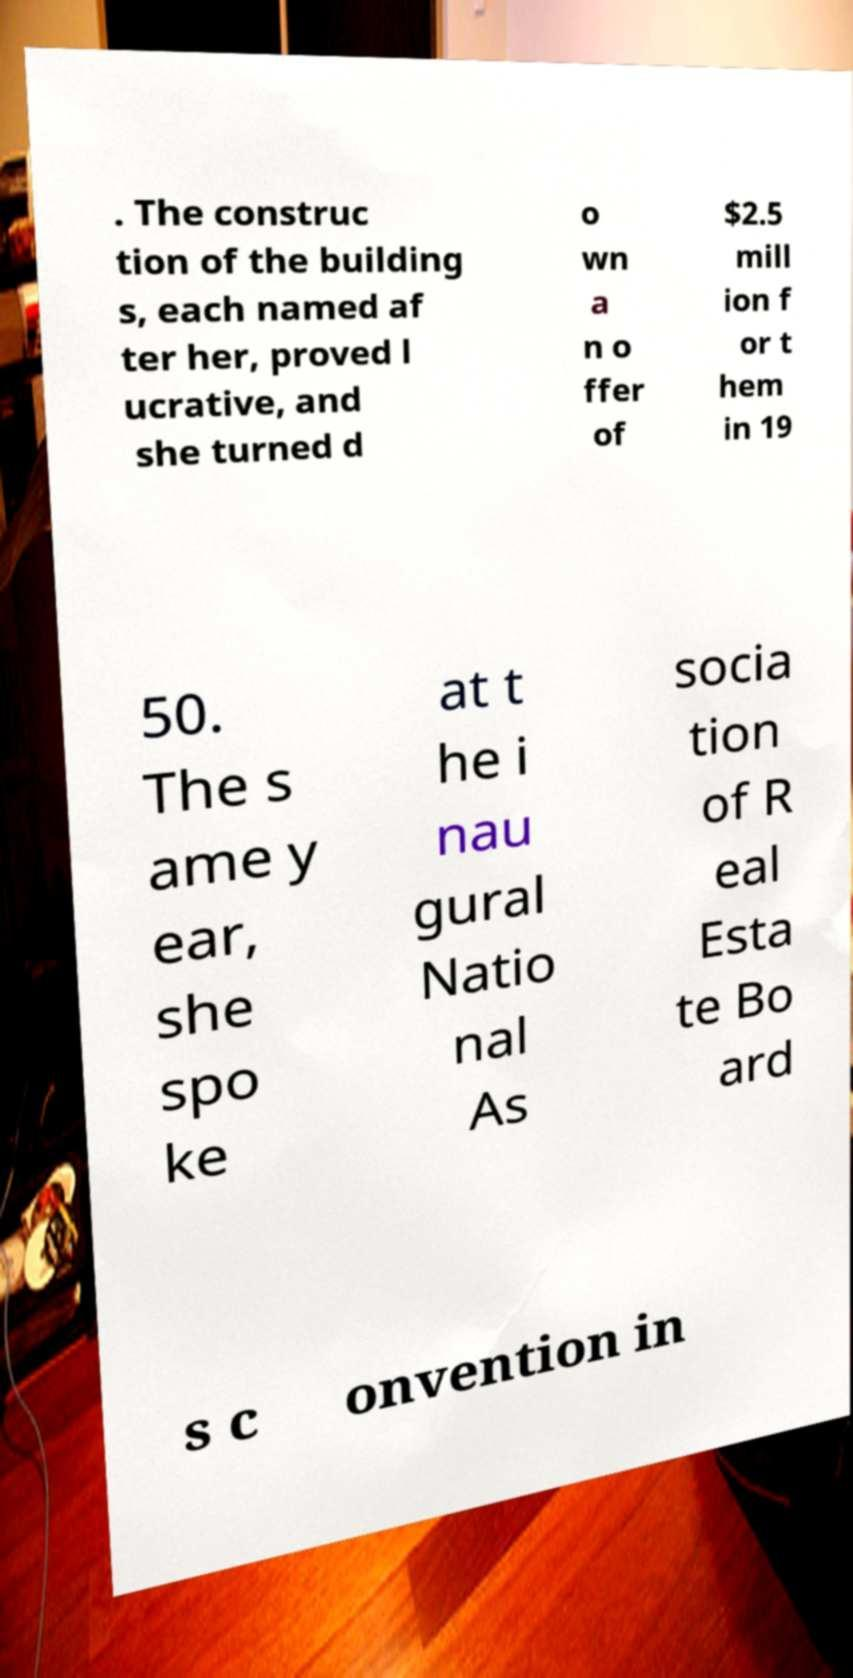For documentation purposes, I need the text within this image transcribed. Could you provide that? . The construc tion of the building s, each named af ter her, proved l ucrative, and she turned d o wn a n o ffer of $2.5 mill ion f or t hem in 19 50. The s ame y ear, she spo ke at t he i nau gural Natio nal As socia tion of R eal Esta te Bo ard s c onvention in 